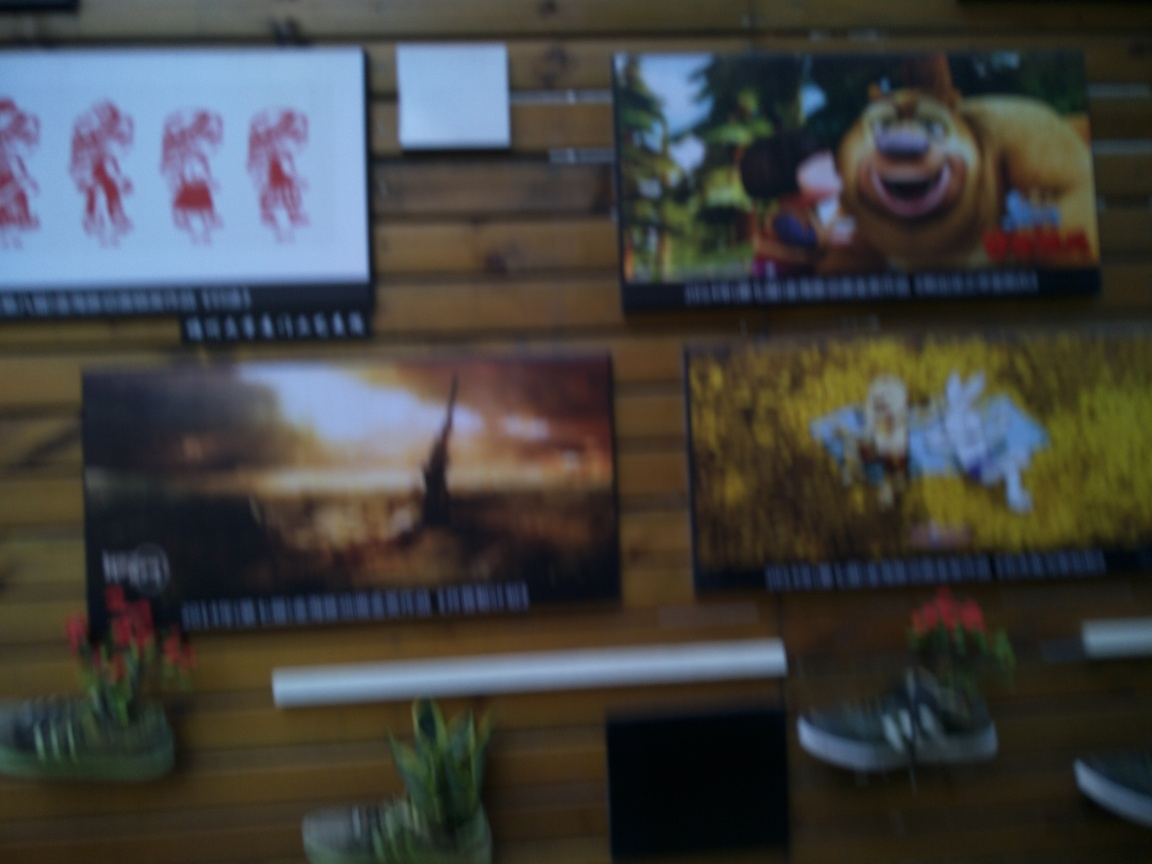Are there any discernible objects in the room other than the pictures? In the foreground, there are what appear to be potted plants, which adds a natural element to the room. Additionally, there seems to be a pair of shoes positioned on a lower shelf or stand. Other items are difficult to make out due to the blurriness of the image, but these elements indicate that the room might be a lived-in space or one that's staged to feel inviting. 